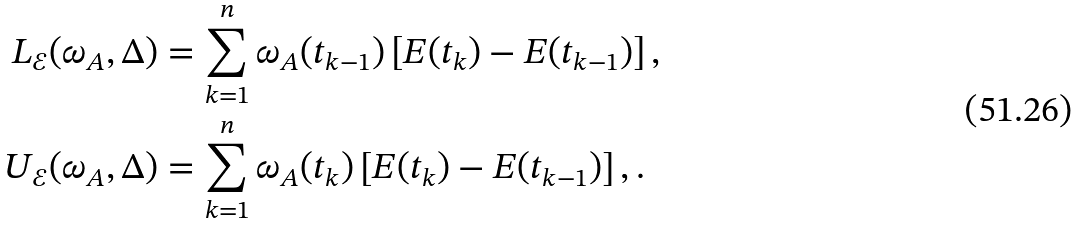<formula> <loc_0><loc_0><loc_500><loc_500>L _ { \mathcal { E } } ( \omega _ { A } , \Delta ) & = \sum _ { k = 1 } ^ { n } \omega _ { A } ( t _ { k - 1 } ) \left [ E ( t _ { k } ) - E ( t _ { k - 1 } ) \right ] , \\ U _ { \mathcal { E } } ( \omega _ { A } , \Delta ) & = \sum _ { k = 1 } ^ { n } \omega _ { A } ( t _ { k } ) \left [ E ( t _ { k } ) - E ( t _ { k - 1 } ) \right ] , .</formula> 